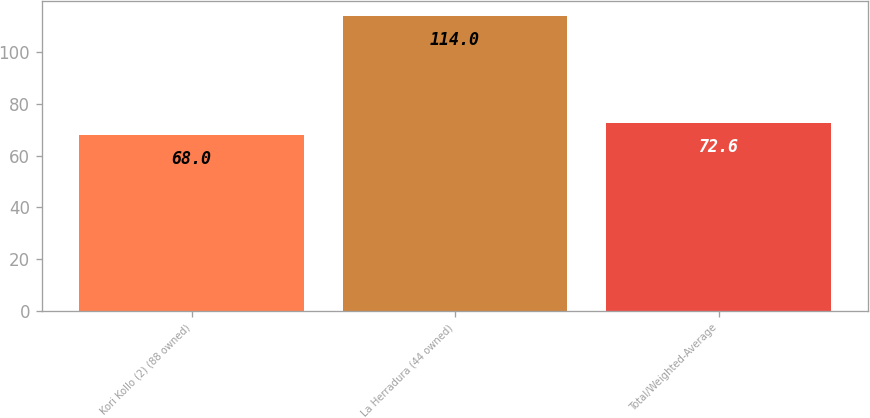Convert chart. <chart><loc_0><loc_0><loc_500><loc_500><bar_chart><fcel>Kori Kollo (2) (88 owned)<fcel>La Herradura (44 owned)<fcel>Total/Weighted-Average<nl><fcel>68<fcel>114<fcel>72.6<nl></chart> 